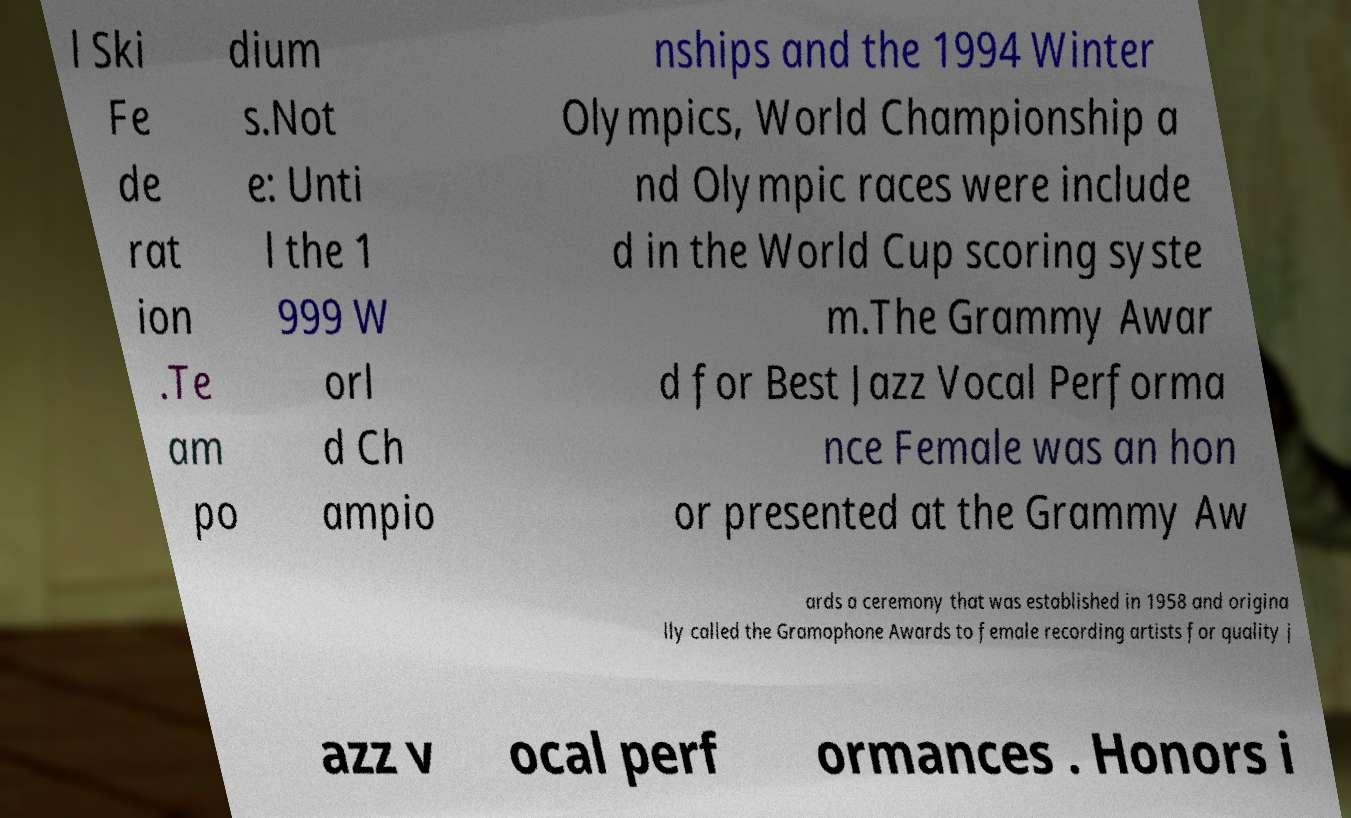What messages or text are displayed in this image? I need them in a readable, typed format. l Ski Fe de rat ion .Te am po dium s.Not e: Unti l the 1 999 W orl d Ch ampio nships and the 1994 Winter Olympics, World Championship a nd Olympic races were include d in the World Cup scoring syste m.The Grammy Awar d for Best Jazz Vocal Performa nce Female was an hon or presented at the Grammy Aw ards a ceremony that was established in 1958 and origina lly called the Gramophone Awards to female recording artists for quality j azz v ocal perf ormances . Honors i 